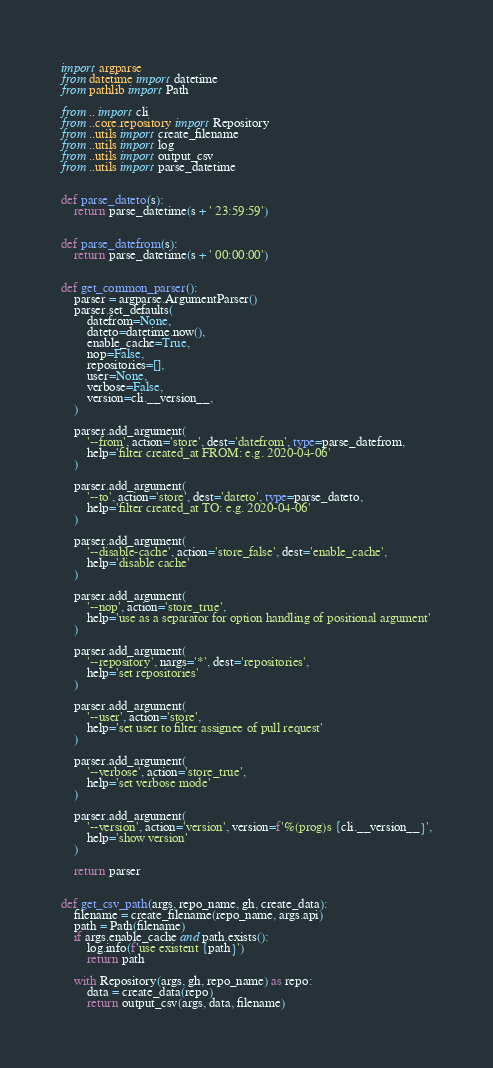Convert code to text. <code><loc_0><loc_0><loc_500><loc_500><_Python_>import argparse
from datetime import datetime
from pathlib import Path

from .. import cli
from ..core.repository import Repository
from ..utils import create_filename
from ..utils import log
from ..utils import output_csv
from ..utils import parse_datetime


def parse_dateto(s):
    return parse_datetime(s + ' 23:59:59')


def parse_datefrom(s):
    return parse_datetime(s + ' 00:00:00')


def get_common_parser():
    parser = argparse.ArgumentParser()
    parser.set_defaults(
        datefrom=None,
        dateto=datetime.now(),
        enable_cache=True,
        nop=False,
        repositories=[],
        user=None,
        verbose=False,
        version=cli.__version__,
    )

    parser.add_argument(
        '--from', action='store', dest='datefrom', type=parse_datefrom,
        help='filter created_at FROM: e.g. 2020-04-06'
    )

    parser.add_argument(
        '--to', action='store', dest='dateto', type=parse_dateto,
        help='filter created_at TO: e.g. 2020-04-06'
    )

    parser.add_argument(
        '--disable-cache', action='store_false', dest='enable_cache',
        help='disable cache'
    )

    parser.add_argument(
        '--nop', action='store_true',
        help='use as a separator for option handling of positional argument'
    )

    parser.add_argument(
        '--repository', nargs='*', dest='repositories',
        help='set repositories'
    )

    parser.add_argument(
        '--user', action='store',
        help='set user to filter assignee of pull request'
    )

    parser.add_argument(
        '--verbose', action='store_true',
        help='set verbose mode'
    )

    parser.add_argument(
        '--version', action='version', version=f'%(prog)s {cli.__version__}',
        help='show version'
    )

    return parser


def get_csv_path(args, repo_name, gh, create_data):
    filename = create_filename(repo_name, args.api)
    path = Path(filename)
    if args.enable_cache and path.exists():
        log.info(f'use existent {path}')
        return path

    with Repository(args, gh, repo_name) as repo:
        data = create_data(repo)
        return output_csv(args, data, filename)
</code> 